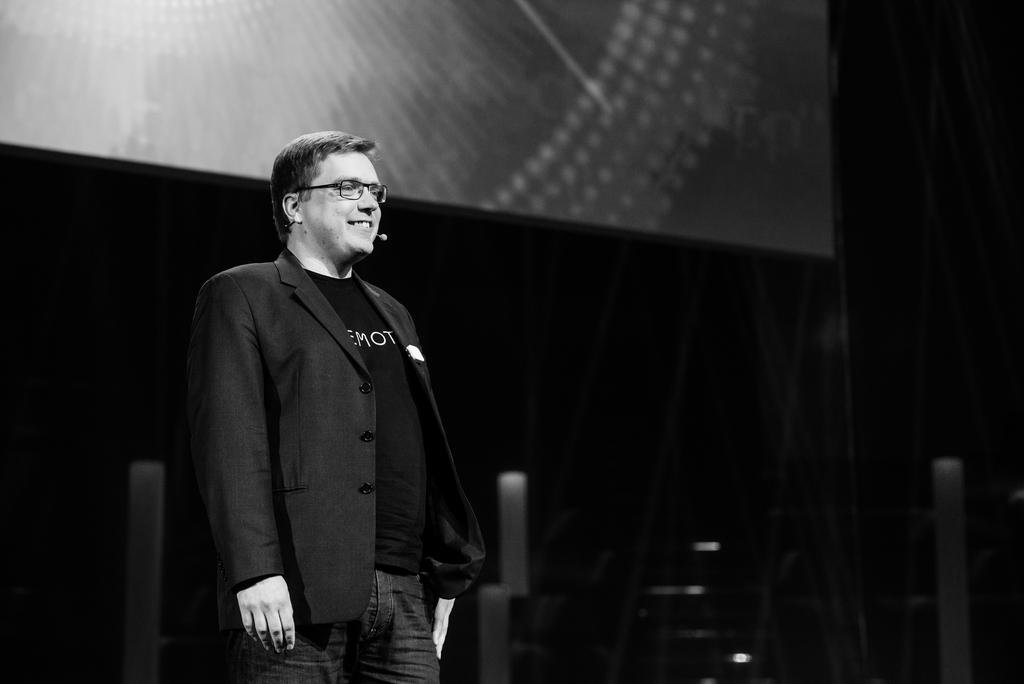What is the color scheme of the image? The image is black and white. What is the person in the image doing? The person is standing on a dais. What can be seen in the background of the image? There is a wall and a screen in the background of the image. How many dogs and cats are visible in the image? There are no dogs or cats present in the image. 